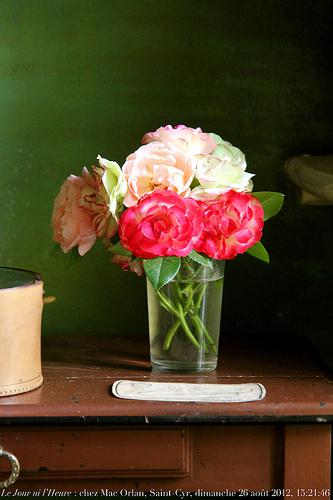Question: what type of picture is this?
Choices:
A. Abstract.
B. Modern.
C. Still life.
D. Contemporary.
Answer with the letter. Answer: C Question: how many red flowers are in this picture?
Choices:
A. Ten.
B. Five.
C. Two.
D. Seven.
Answer with the letter. Answer: C Question: what are the flowers in?
Choices:
A. A vase.
B. A cup.
C. A mug.
D. A jar.
Answer with the letter. Answer: A Question: what color is the wall?
Choices:
A. Blue.
B. Orange.
C. Green.
D. Grey.
Answer with the letter. Answer: C Question: what material is the vase made of?
Choices:
A. Plastic.
B. Metal.
C. Acrylic.
D. Glass.
Answer with the letter. Answer: D Question: where are the flowers?
Choices:
A. On a shelf.
B. On a window sill.
C. On a chair.
D. On a desk.
Answer with the letter. Answer: D 